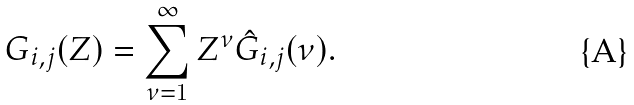<formula> <loc_0><loc_0><loc_500><loc_500>G _ { i , j } ( Z ) = \sum _ { \nu = 1 } ^ { \infty } Z ^ { \nu } \hat { G } _ { i , j } ( \nu ) .</formula> 